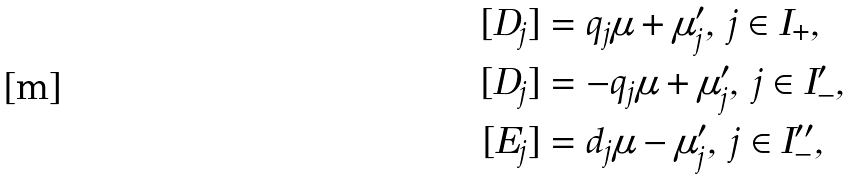Convert formula to latex. <formula><loc_0><loc_0><loc_500><loc_500>[ D _ { j } ] & = q _ { j } \mu + \mu _ { j } ^ { \prime } , \, j \in I _ { + } , \\ [ D _ { j } ] & = - q _ { j } \mu + \mu _ { j } ^ { \prime } , \, j \in I _ { - } ^ { \prime } , \\ [ E _ { j } ] & = d _ { j } \mu - \mu _ { j } ^ { \prime } , \, j \in I _ { - } ^ { \prime \prime } ,</formula> 